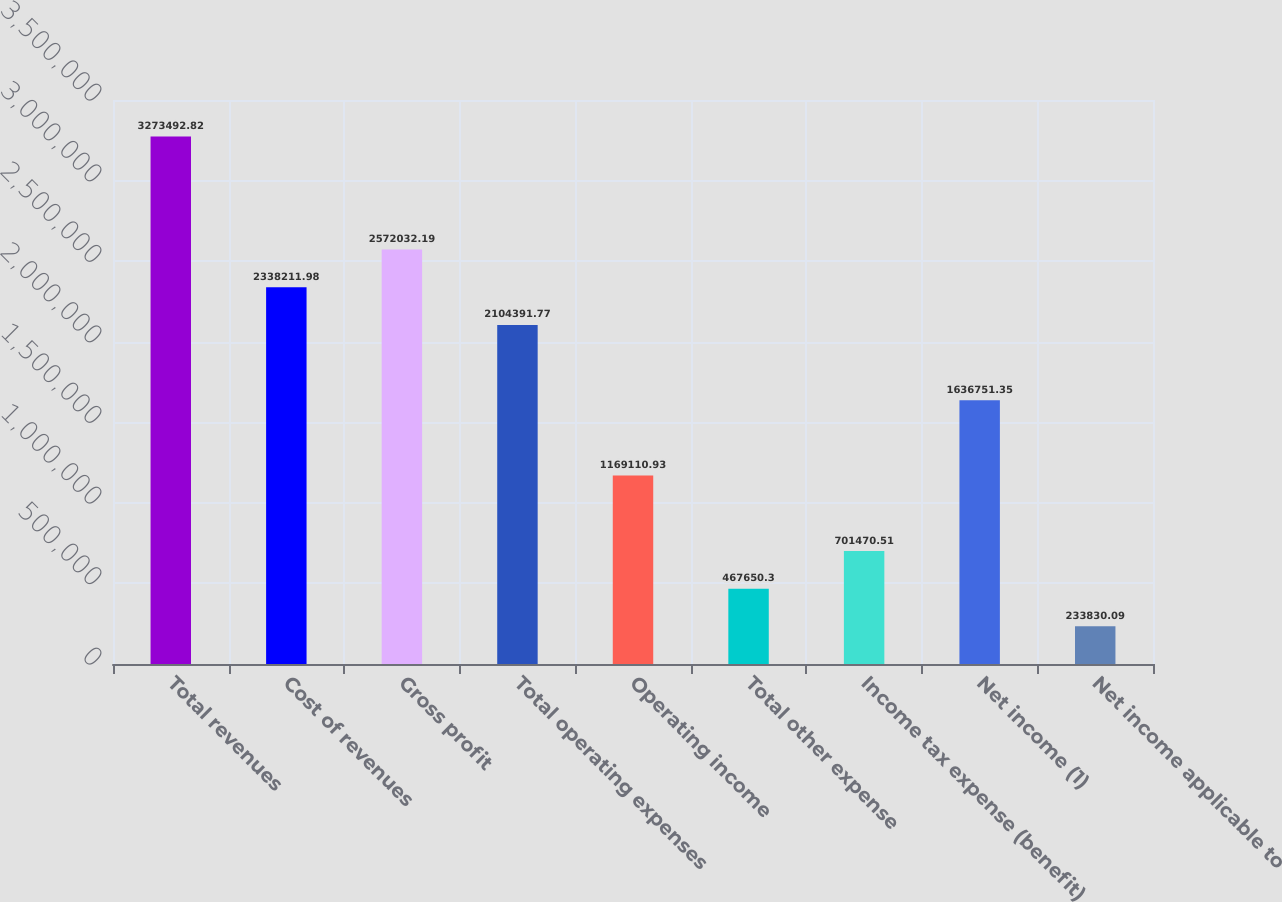Convert chart. <chart><loc_0><loc_0><loc_500><loc_500><bar_chart><fcel>Total revenues<fcel>Cost of revenues<fcel>Gross profit<fcel>Total operating expenses<fcel>Operating income<fcel>Total other expense<fcel>Income tax expense (benefit)<fcel>Net income (1)<fcel>Net income applicable to<nl><fcel>3.27349e+06<fcel>2.33821e+06<fcel>2.57203e+06<fcel>2.10439e+06<fcel>1.16911e+06<fcel>467650<fcel>701471<fcel>1.63675e+06<fcel>233830<nl></chart> 